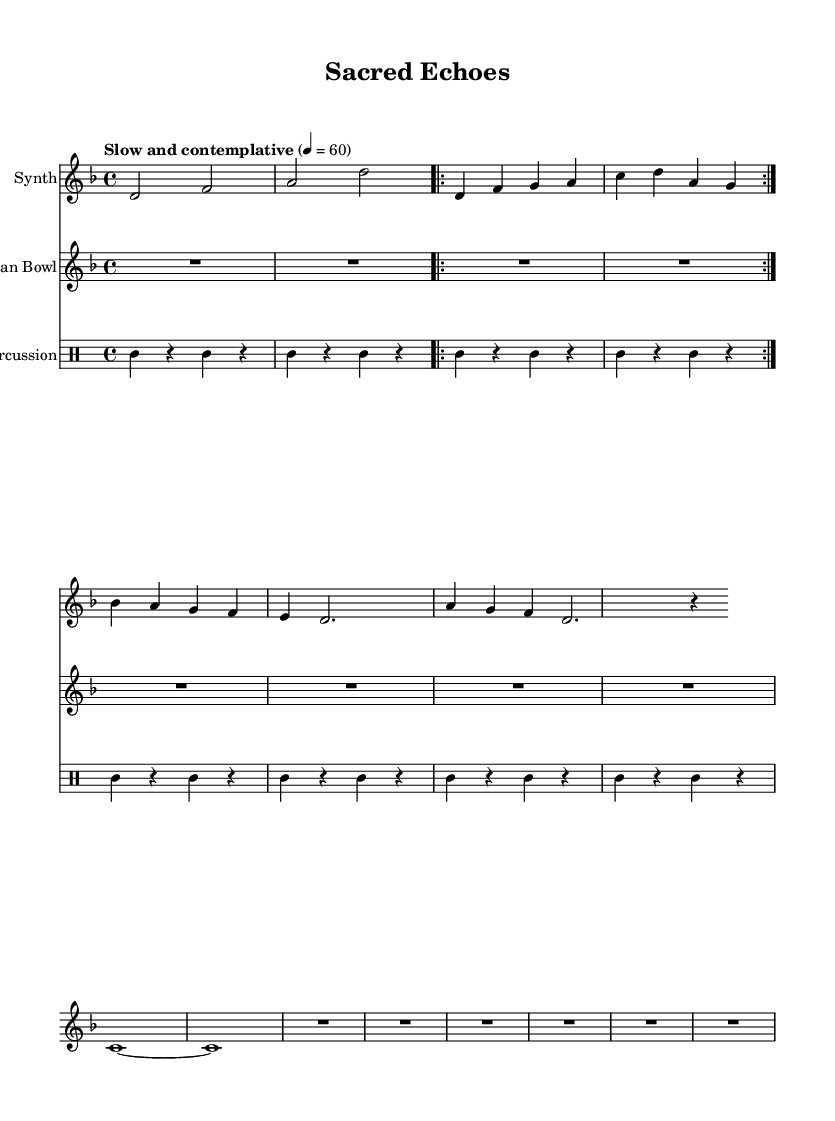What is the key signature of this music? The key signature is indicated at the beginning of the staff, which shows 1 flat, identifying it as D minor.
Answer: D minor What is the time signature of this piece? The time signature is presented at the start of the score, displaying a 4 over 4, meaning there are four beats per measure.
Answer: 4/4 What is the tempo marking given for this piece? The tempo marking is located above the staff and describes the desired speed and mood for performance, indicating it should be "Slow and contemplative."
Answer: Slow and contemplative How many times is Theme A repeated? Theme A is explicitly marked with a repeat sign (volta), indicating it should be played twice before moving on to the next theme.
Answer: 2 Which instrument plays the Tibetan bowl part? The Tibetan Bowl part is labeled in the score under the respective staff, indicating that this portion is played by the Tibetan bowl instrument.
Answer: Tibetan Bowl What rhythm pattern does the percussion follow? The percussion staff shows a consistent rhythmic pattern throughout the measures with an alternating pattern of quarter-note and rest, indicating a steady beat.
Answer: Alternating quarter-note and rest What type of sound does the synthesis part aim to produce in this piece? The synthesis part is designed to create an ethereal soundscape, using a blend of sustained notes and unfolding themes to evoke mood, consistent with the overall theme of religious diversity.
Answer: Ethereal soundscape 